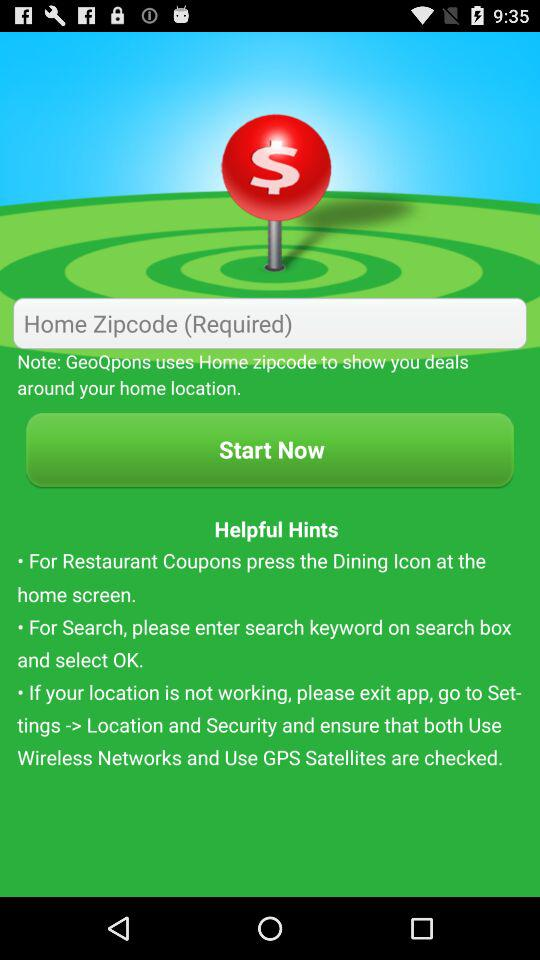What is required to show deals around the home location? To show deals around the home location, the home zip code is required. 